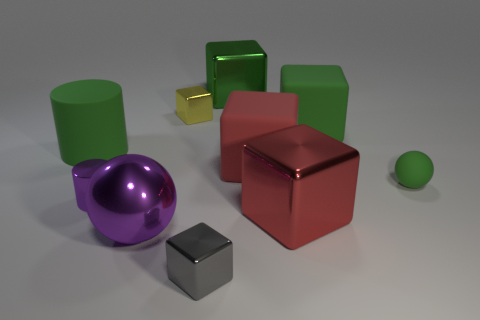Subtract all tiny yellow shiny cubes. How many cubes are left? 5 Subtract all green cubes. How many cubes are left? 4 Subtract 1 balls. How many balls are left? 1 Subtract all green cylinders. How many red blocks are left? 2 Subtract all cylinders. How many objects are left? 8 Subtract all gray cubes. Subtract all purple cylinders. How many cubes are left? 5 Subtract all tiny rubber spheres. Subtract all big blue balls. How many objects are left? 9 Add 3 large green things. How many large green things are left? 6 Add 7 purple matte things. How many purple matte things exist? 7 Subtract 0 red cylinders. How many objects are left? 10 